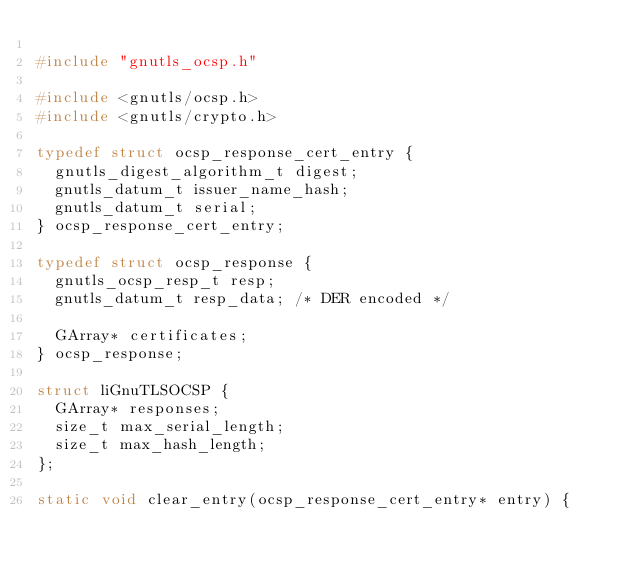<code> <loc_0><loc_0><loc_500><loc_500><_C_>
#include "gnutls_ocsp.h"

#include <gnutls/ocsp.h>
#include <gnutls/crypto.h>

typedef struct ocsp_response_cert_entry {
	gnutls_digest_algorithm_t digest;
	gnutls_datum_t issuer_name_hash;
	gnutls_datum_t serial;
} ocsp_response_cert_entry;

typedef struct ocsp_response {
	gnutls_ocsp_resp_t resp;
	gnutls_datum_t resp_data; /* DER encoded */

	GArray* certificates;
} ocsp_response;

struct liGnuTLSOCSP {
	GArray* responses;
	size_t max_serial_length;
	size_t max_hash_length;
};

static void clear_entry(ocsp_response_cert_entry* entry) {</code> 